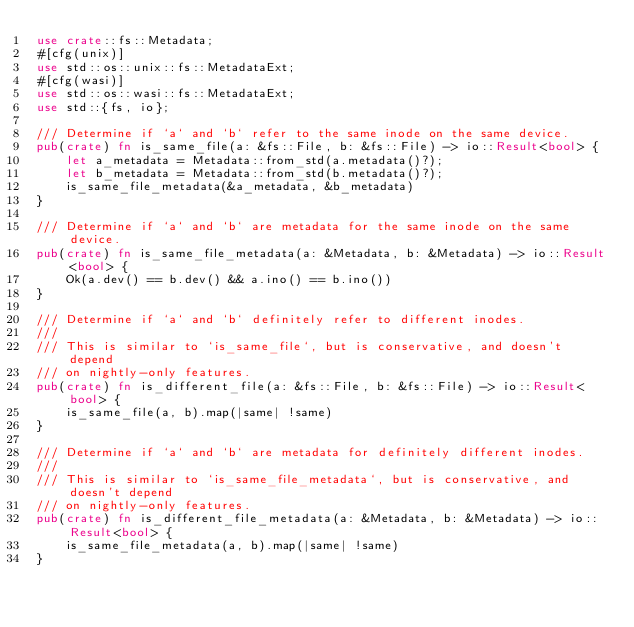<code> <loc_0><loc_0><loc_500><loc_500><_Rust_>use crate::fs::Metadata;
#[cfg(unix)]
use std::os::unix::fs::MetadataExt;
#[cfg(wasi)]
use std::os::wasi::fs::MetadataExt;
use std::{fs, io};

/// Determine if `a` and `b` refer to the same inode on the same device.
pub(crate) fn is_same_file(a: &fs::File, b: &fs::File) -> io::Result<bool> {
    let a_metadata = Metadata::from_std(a.metadata()?);
    let b_metadata = Metadata::from_std(b.metadata()?);
    is_same_file_metadata(&a_metadata, &b_metadata)
}

/// Determine if `a` and `b` are metadata for the same inode on the same device.
pub(crate) fn is_same_file_metadata(a: &Metadata, b: &Metadata) -> io::Result<bool> {
    Ok(a.dev() == b.dev() && a.ino() == b.ino())
}

/// Determine if `a` and `b` definitely refer to different inodes.
///
/// This is similar to `is_same_file`, but is conservative, and doesn't depend
/// on nightly-only features.
pub(crate) fn is_different_file(a: &fs::File, b: &fs::File) -> io::Result<bool> {
    is_same_file(a, b).map(|same| !same)
}

/// Determine if `a` and `b` are metadata for definitely different inodes.
///
/// This is similar to `is_same_file_metadata`, but is conservative, and doesn't depend
/// on nightly-only features.
pub(crate) fn is_different_file_metadata(a: &Metadata, b: &Metadata) -> io::Result<bool> {
    is_same_file_metadata(a, b).map(|same| !same)
}
</code> 